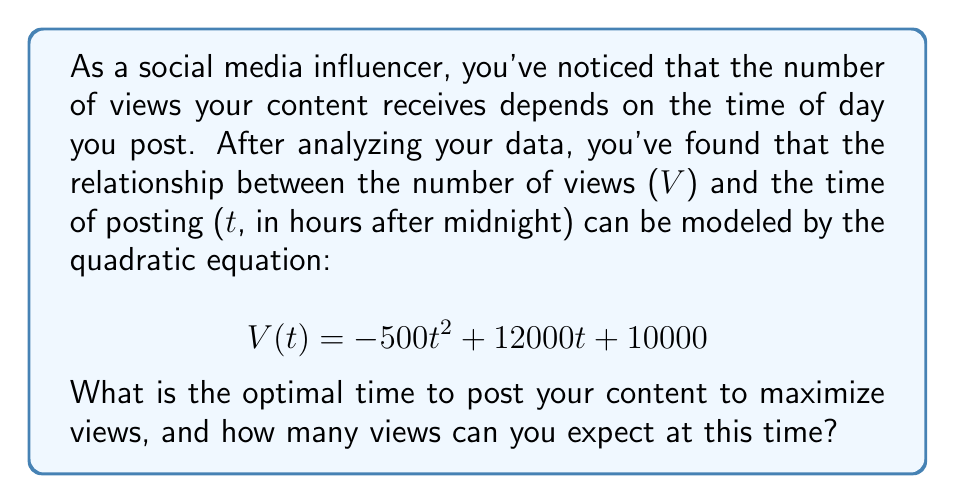Provide a solution to this math problem. To find the optimal time for posting, we need to determine the maximum of the quadratic function. This occurs at the vertex of the parabola. For a quadratic function in the form $f(t) = at^2 + bt + c$, the t-coordinate of the vertex is given by $t = -\frac{b}{2a}$.

1. Identify the coefficients:
   $a = -500$, $b = 12000$, $c = 10000$

2. Calculate the optimal time:
   $t = -\frac{b}{2a} = -\frac{12000}{2(-500)} = \frac{12000}{1000} = 12$

3. The optimal time to post is 12 hours after midnight, or 12:00 PM.

4. To find the maximum number of views, substitute $t = 12$ into the original equation:

   $$ V(12) = -500(12)^2 + 12000(12) + 10000 $$
   $$ = -500(144) + 144000 + 10000 $$
   $$ = -72000 + 144000 + 10000 $$
   $$ = 82000 $$

Therefore, at the optimal posting time of 12:00 PM, you can expect to receive 82,000 views.
Answer: 12:00 PM; 82,000 views 